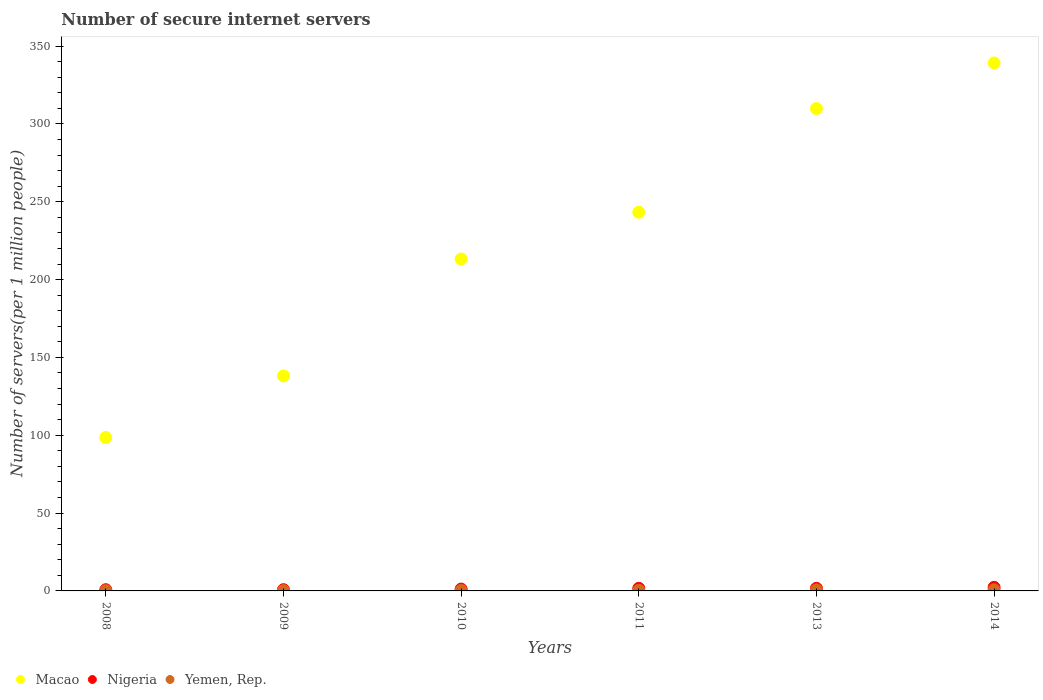What is the number of secure internet servers in Nigeria in 2008?
Offer a terse response. 0.79. Across all years, what is the maximum number of secure internet servers in Yemen, Rep.?
Give a very brief answer. 0.73. Across all years, what is the minimum number of secure internet servers in Yemen, Rep.?
Your response must be concise. 0.18. In which year was the number of secure internet servers in Macao maximum?
Provide a short and direct response. 2014. In which year was the number of secure internet servers in Macao minimum?
Provide a succinct answer. 2008. What is the total number of secure internet servers in Yemen, Rep. in the graph?
Your response must be concise. 2.46. What is the difference between the number of secure internet servers in Macao in 2010 and that in 2011?
Your answer should be very brief. -30.05. What is the difference between the number of secure internet servers in Macao in 2009 and the number of secure internet servers in Nigeria in 2010?
Your answer should be very brief. 136.89. What is the average number of secure internet servers in Macao per year?
Provide a short and direct response. 223.69. In the year 2014, what is the difference between the number of secure internet servers in Yemen, Rep. and number of secure internet servers in Macao?
Offer a very short reply. -338.43. What is the ratio of the number of secure internet servers in Yemen, Rep. in 2008 to that in 2009?
Your response must be concise. 0.82. Is the number of secure internet servers in Nigeria in 2009 less than that in 2010?
Make the answer very short. Yes. What is the difference between the highest and the second highest number of secure internet servers in Yemen, Rep.?
Make the answer very short. 0.1. What is the difference between the highest and the lowest number of secure internet servers in Nigeria?
Your answer should be very brief. 1.53. Is the sum of the number of secure internet servers in Yemen, Rep. in 2008 and 2013 greater than the maximum number of secure internet servers in Macao across all years?
Your answer should be compact. No. Is it the case that in every year, the sum of the number of secure internet servers in Macao and number of secure internet servers in Yemen, Rep.  is greater than the number of secure internet servers in Nigeria?
Ensure brevity in your answer.  Yes. Does the number of secure internet servers in Macao monotonically increase over the years?
Make the answer very short. Yes. Is the number of secure internet servers in Nigeria strictly less than the number of secure internet servers in Macao over the years?
Keep it short and to the point. Yes. How many years are there in the graph?
Provide a succinct answer. 6. Does the graph contain any zero values?
Your response must be concise. No. Does the graph contain grids?
Your response must be concise. No. How many legend labels are there?
Make the answer very short. 3. What is the title of the graph?
Provide a short and direct response. Number of secure internet servers. Does "Morocco" appear as one of the legend labels in the graph?
Ensure brevity in your answer.  No. What is the label or title of the Y-axis?
Keep it short and to the point. Number of servers(per 1 million people). What is the Number of servers(per 1 million people) in Macao in 2008?
Provide a succinct answer. 98.57. What is the Number of servers(per 1 million people) of Nigeria in 2008?
Offer a very short reply. 0.79. What is the Number of servers(per 1 million people) of Yemen, Rep. in 2008?
Keep it short and to the point. 0.18. What is the Number of servers(per 1 million people) of Macao in 2009?
Provide a short and direct response. 138.09. What is the Number of servers(per 1 million people) of Nigeria in 2009?
Give a very brief answer. 0.81. What is the Number of servers(per 1 million people) in Yemen, Rep. in 2009?
Make the answer very short. 0.22. What is the Number of servers(per 1 million people) in Macao in 2010?
Offer a very short reply. 213.23. What is the Number of servers(per 1 million people) of Nigeria in 2010?
Make the answer very short. 1.2. What is the Number of servers(per 1 million people) in Yemen, Rep. in 2010?
Give a very brief answer. 0.3. What is the Number of servers(per 1 million people) in Macao in 2011?
Your answer should be compact. 243.29. What is the Number of servers(per 1 million people) in Nigeria in 2011?
Your response must be concise. 1.68. What is the Number of servers(per 1 million people) of Yemen, Rep. in 2011?
Offer a very short reply. 0.41. What is the Number of servers(per 1 million people) in Macao in 2013?
Offer a terse response. 309.83. What is the Number of servers(per 1 million people) of Nigeria in 2013?
Provide a succinct answer. 1.68. What is the Number of servers(per 1 million people) of Yemen, Rep. in 2013?
Ensure brevity in your answer.  0.63. What is the Number of servers(per 1 million people) in Macao in 2014?
Your answer should be compact. 339.15. What is the Number of servers(per 1 million people) of Nigeria in 2014?
Your response must be concise. 2.32. What is the Number of servers(per 1 million people) of Yemen, Rep. in 2014?
Give a very brief answer. 0.73. Across all years, what is the maximum Number of servers(per 1 million people) of Macao?
Your answer should be very brief. 339.15. Across all years, what is the maximum Number of servers(per 1 million people) of Nigeria?
Your response must be concise. 2.32. Across all years, what is the maximum Number of servers(per 1 million people) of Yemen, Rep.?
Keep it short and to the point. 0.73. Across all years, what is the minimum Number of servers(per 1 million people) in Macao?
Give a very brief answer. 98.57. Across all years, what is the minimum Number of servers(per 1 million people) in Nigeria?
Make the answer very short. 0.79. Across all years, what is the minimum Number of servers(per 1 million people) of Yemen, Rep.?
Make the answer very short. 0.18. What is the total Number of servers(per 1 million people) in Macao in the graph?
Provide a succinct answer. 1342.15. What is the total Number of servers(per 1 million people) in Nigeria in the graph?
Your answer should be very brief. 8.48. What is the total Number of servers(per 1 million people) of Yemen, Rep. in the graph?
Your answer should be very brief. 2.46. What is the difference between the Number of servers(per 1 million people) in Macao in 2008 and that in 2009?
Your answer should be very brief. -39.52. What is the difference between the Number of servers(per 1 million people) in Nigeria in 2008 and that in 2009?
Provide a short and direct response. -0.01. What is the difference between the Number of servers(per 1 million people) of Yemen, Rep. in 2008 and that in 2009?
Ensure brevity in your answer.  -0.04. What is the difference between the Number of servers(per 1 million people) of Macao in 2008 and that in 2010?
Keep it short and to the point. -114.67. What is the difference between the Number of servers(per 1 million people) in Nigeria in 2008 and that in 2010?
Offer a terse response. -0.4. What is the difference between the Number of servers(per 1 million people) of Yemen, Rep. in 2008 and that in 2010?
Offer a very short reply. -0.12. What is the difference between the Number of servers(per 1 million people) of Macao in 2008 and that in 2011?
Offer a terse response. -144.72. What is the difference between the Number of servers(per 1 million people) of Nigeria in 2008 and that in 2011?
Give a very brief answer. -0.89. What is the difference between the Number of servers(per 1 million people) of Yemen, Rep. in 2008 and that in 2011?
Your answer should be very brief. -0.23. What is the difference between the Number of servers(per 1 million people) of Macao in 2008 and that in 2013?
Provide a succinct answer. -211.26. What is the difference between the Number of servers(per 1 million people) in Nigeria in 2008 and that in 2013?
Your answer should be very brief. -0.89. What is the difference between the Number of servers(per 1 million people) of Yemen, Rep. in 2008 and that in 2013?
Offer a terse response. -0.45. What is the difference between the Number of servers(per 1 million people) in Macao in 2008 and that in 2014?
Ensure brevity in your answer.  -240.58. What is the difference between the Number of servers(per 1 million people) of Nigeria in 2008 and that in 2014?
Provide a short and direct response. -1.53. What is the difference between the Number of servers(per 1 million people) in Yemen, Rep. in 2008 and that in 2014?
Give a very brief answer. -0.55. What is the difference between the Number of servers(per 1 million people) in Macao in 2009 and that in 2010?
Your answer should be compact. -75.14. What is the difference between the Number of servers(per 1 million people) in Nigeria in 2009 and that in 2010?
Offer a terse response. -0.39. What is the difference between the Number of servers(per 1 million people) of Yemen, Rep. in 2009 and that in 2010?
Your answer should be very brief. -0.08. What is the difference between the Number of servers(per 1 million people) of Macao in 2009 and that in 2011?
Offer a terse response. -105.2. What is the difference between the Number of servers(per 1 million people) in Nigeria in 2009 and that in 2011?
Give a very brief answer. -0.87. What is the difference between the Number of servers(per 1 million people) in Yemen, Rep. in 2009 and that in 2011?
Your response must be concise. -0.19. What is the difference between the Number of servers(per 1 million people) of Macao in 2009 and that in 2013?
Your answer should be very brief. -171.74. What is the difference between the Number of servers(per 1 million people) in Nigeria in 2009 and that in 2013?
Provide a short and direct response. -0.88. What is the difference between the Number of servers(per 1 million people) in Yemen, Rep. in 2009 and that in 2013?
Offer a very short reply. -0.41. What is the difference between the Number of servers(per 1 million people) in Macao in 2009 and that in 2014?
Provide a succinct answer. -201.06. What is the difference between the Number of servers(per 1 million people) in Nigeria in 2009 and that in 2014?
Your answer should be compact. -1.52. What is the difference between the Number of servers(per 1 million people) of Yemen, Rep. in 2009 and that in 2014?
Provide a short and direct response. -0.51. What is the difference between the Number of servers(per 1 million people) of Macao in 2010 and that in 2011?
Your answer should be very brief. -30.05. What is the difference between the Number of servers(per 1 million people) of Nigeria in 2010 and that in 2011?
Your answer should be compact. -0.48. What is the difference between the Number of servers(per 1 million people) in Yemen, Rep. in 2010 and that in 2011?
Your answer should be compact. -0.12. What is the difference between the Number of servers(per 1 million people) of Macao in 2010 and that in 2013?
Your response must be concise. -96.6. What is the difference between the Number of servers(per 1 million people) in Nigeria in 2010 and that in 2013?
Your answer should be very brief. -0.49. What is the difference between the Number of servers(per 1 million people) of Yemen, Rep. in 2010 and that in 2013?
Your answer should be very brief. -0.33. What is the difference between the Number of servers(per 1 million people) in Macao in 2010 and that in 2014?
Make the answer very short. -125.92. What is the difference between the Number of servers(per 1 million people) in Nigeria in 2010 and that in 2014?
Your answer should be compact. -1.12. What is the difference between the Number of servers(per 1 million people) in Yemen, Rep. in 2010 and that in 2014?
Your answer should be very brief. -0.43. What is the difference between the Number of servers(per 1 million people) of Macao in 2011 and that in 2013?
Make the answer very short. -66.54. What is the difference between the Number of servers(per 1 million people) of Nigeria in 2011 and that in 2013?
Offer a terse response. -0. What is the difference between the Number of servers(per 1 million people) in Yemen, Rep. in 2011 and that in 2013?
Make the answer very short. -0.21. What is the difference between the Number of servers(per 1 million people) of Macao in 2011 and that in 2014?
Your response must be concise. -95.86. What is the difference between the Number of servers(per 1 million people) in Nigeria in 2011 and that in 2014?
Your answer should be compact. -0.64. What is the difference between the Number of servers(per 1 million people) of Yemen, Rep. in 2011 and that in 2014?
Your response must be concise. -0.31. What is the difference between the Number of servers(per 1 million people) in Macao in 2013 and that in 2014?
Your response must be concise. -29.32. What is the difference between the Number of servers(per 1 million people) in Nigeria in 2013 and that in 2014?
Your answer should be compact. -0.64. What is the difference between the Number of servers(per 1 million people) in Yemen, Rep. in 2013 and that in 2014?
Keep it short and to the point. -0.1. What is the difference between the Number of servers(per 1 million people) of Macao in 2008 and the Number of servers(per 1 million people) of Nigeria in 2009?
Give a very brief answer. 97.76. What is the difference between the Number of servers(per 1 million people) in Macao in 2008 and the Number of servers(per 1 million people) in Yemen, Rep. in 2009?
Your answer should be very brief. 98.35. What is the difference between the Number of servers(per 1 million people) of Nigeria in 2008 and the Number of servers(per 1 million people) of Yemen, Rep. in 2009?
Provide a short and direct response. 0.58. What is the difference between the Number of servers(per 1 million people) of Macao in 2008 and the Number of servers(per 1 million people) of Nigeria in 2010?
Offer a very short reply. 97.37. What is the difference between the Number of servers(per 1 million people) in Macao in 2008 and the Number of servers(per 1 million people) in Yemen, Rep. in 2010?
Provide a succinct answer. 98.27. What is the difference between the Number of servers(per 1 million people) in Nigeria in 2008 and the Number of servers(per 1 million people) in Yemen, Rep. in 2010?
Make the answer very short. 0.5. What is the difference between the Number of servers(per 1 million people) of Macao in 2008 and the Number of servers(per 1 million people) of Nigeria in 2011?
Offer a very short reply. 96.89. What is the difference between the Number of servers(per 1 million people) in Macao in 2008 and the Number of servers(per 1 million people) in Yemen, Rep. in 2011?
Give a very brief answer. 98.15. What is the difference between the Number of servers(per 1 million people) in Nigeria in 2008 and the Number of servers(per 1 million people) in Yemen, Rep. in 2011?
Provide a short and direct response. 0.38. What is the difference between the Number of servers(per 1 million people) of Macao in 2008 and the Number of servers(per 1 million people) of Nigeria in 2013?
Your answer should be compact. 96.88. What is the difference between the Number of servers(per 1 million people) of Macao in 2008 and the Number of servers(per 1 million people) of Yemen, Rep. in 2013?
Provide a short and direct response. 97.94. What is the difference between the Number of servers(per 1 million people) of Nigeria in 2008 and the Number of servers(per 1 million people) of Yemen, Rep. in 2013?
Ensure brevity in your answer.  0.17. What is the difference between the Number of servers(per 1 million people) in Macao in 2008 and the Number of servers(per 1 million people) in Nigeria in 2014?
Provide a succinct answer. 96.24. What is the difference between the Number of servers(per 1 million people) in Macao in 2008 and the Number of servers(per 1 million people) in Yemen, Rep. in 2014?
Your answer should be compact. 97.84. What is the difference between the Number of servers(per 1 million people) in Nigeria in 2008 and the Number of servers(per 1 million people) in Yemen, Rep. in 2014?
Provide a short and direct response. 0.07. What is the difference between the Number of servers(per 1 million people) of Macao in 2009 and the Number of servers(per 1 million people) of Nigeria in 2010?
Keep it short and to the point. 136.89. What is the difference between the Number of servers(per 1 million people) in Macao in 2009 and the Number of servers(per 1 million people) in Yemen, Rep. in 2010?
Make the answer very short. 137.79. What is the difference between the Number of servers(per 1 million people) of Nigeria in 2009 and the Number of servers(per 1 million people) of Yemen, Rep. in 2010?
Make the answer very short. 0.51. What is the difference between the Number of servers(per 1 million people) in Macao in 2009 and the Number of servers(per 1 million people) in Nigeria in 2011?
Provide a succinct answer. 136.41. What is the difference between the Number of servers(per 1 million people) in Macao in 2009 and the Number of servers(per 1 million people) in Yemen, Rep. in 2011?
Your answer should be very brief. 137.68. What is the difference between the Number of servers(per 1 million people) of Nigeria in 2009 and the Number of servers(per 1 million people) of Yemen, Rep. in 2011?
Keep it short and to the point. 0.39. What is the difference between the Number of servers(per 1 million people) in Macao in 2009 and the Number of servers(per 1 million people) in Nigeria in 2013?
Provide a short and direct response. 136.4. What is the difference between the Number of servers(per 1 million people) in Macao in 2009 and the Number of servers(per 1 million people) in Yemen, Rep. in 2013?
Your response must be concise. 137.46. What is the difference between the Number of servers(per 1 million people) of Nigeria in 2009 and the Number of servers(per 1 million people) of Yemen, Rep. in 2013?
Offer a terse response. 0.18. What is the difference between the Number of servers(per 1 million people) of Macao in 2009 and the Number of servers(per 1 million people) of Nigeria in 2014?
Provide a short and direct response. 135.77. What is the difference between the Number of servers(per 1 million people) in Macao in 2009 and the Number of servers(per 1 million people) in Yemen, Rep. in 2014?
Offer a terse response. 137.36. What is the difference between the Number of servers(per 1 million people) in Nigeria in 2009 and the Number of servers(per 1 million people) in Yemen, Rep. in 2014?
Your answer should be compact. 0.08. What is the difference between the Number of servers(per 1 million people) in Macao in 2010 and the Number of servers(per 1 million people) in Nigeria in 2011?
Make the answer very short. 211.55. What is the difference between the Number of servers(per 1 million people) of Macao in 2010 and the Number of servers(per 1 million people) of Yemen, Rep. in 2011?
Offer a terse response. 212.82. What is the difference between the Number of servers(per 1 million people) of Nigeria in 2010 and the Number of servers(per 1 million people) of Yemen, Rep. in 2011?
Give a very brief answer. 0.79. What is the difference between the Number of servers(per 1 million people) in Macao in 2010 and the Number of servers(per 1 million people) in Nigeria in 2013?
Ensure brevity in your answer.  211.55. What is the difference between the Number of servers(per 1 million people) of Macao in 2010 and the Number of servers(per 1 million people) of Yemen, Rep. in 2013?
Provide a succinct answer. 212.61. What is the difference between the Number of servers(per 1 million people) in Nigeria in 2010 and the Number of servers(per 1 million people) in Yemen, Rep. in 2013?
Make the answer very short. 0.57. What is the difference between the Number of servers(per 1 million people) of Macao in 2010 and the Number of servers(per 1 million people) of Nigeria in 2014?
Give a very brief answer. 210.91. What is the difference between the Number of servers(per 1 million people) in Macao in 2010 and the Number of servers(per 1 million people) in Yemen, Rep. in 2014?
Make the answer very short. 212.51. What is the difference between the Number of servers(per 1 million people) in Nigeria in 2010 and the Number of servers(per 1 million people) in Yemen, Rep. in 2014?
Offer a terse response. 0.47. What is the difference between the Number of servers(per 1 million people) of Macao in 2011 and the Number of servers(per 1 million people) of Nigeria in 2013?
Keep it short and to the point. 241.6. What is the difference between the Number of servers(per 1 million people) in Macao in 2011 and the Number of servers(per 1 million people) in Yemen, Rep. in 2013?
Provide a short and direct response. 242.66. What is the difference between the Number of servers(per 1 million people) of Nigeria in 2011 and the Number of servers(per 1 million people) of Yemen, Rep. in 2013?
Provide a succinct answer. 1.05. What is the difference between the Number of servers(per 1 million people) of Macao in 2011 and the Number of servers(per 1 million people) of Nigeria in 2014?
Provide a short and direct response. 240.96. What is the difference between the Number of servers(per 1 million people) in Macao in 2011 and the Number of servers(per 1 million people) in Yemen, Rep. in 2014?
Give a very brief answer. 242.56. What is the difference between the Number of servers(per 1 million people) in Nigeria in 2011 and the Number of servers(per 1 million people) in Yemen, Rep. in 2014?
Your answer should be compact. 0.95. What is the difference between the Number of servers(per 1 million people) in Macao in 2013 and the Number of servers(per 1 million people) in Nigeria in 2014?
Your answer should be very brief. 307.51. What is the difference between the Number of servers(per 1 million people) in Macao in 2013 and the Number of servers(per 1 million people) in Yemen, Rep. in 2014?
Your answer should be very brief. 309.1. What is the difference between the Number of servers(per 1 million people) in Nigeria in 2013 and the Number of servers(per 1 million people) in Yemen, Rep. in 2014?
Provide a succinct answer. 0.96. What is the average Number of servers(per 1 million people) in Macao per year?
Your answer should be very brief. 223.69. What is the average Number of servers(per 1 million people) of Nigeria per year?
Make the answer very short. 1.41. What is the average Number of servers(per 1 million people) in Yemen, Rep. per year?
Make the answer very short. 0.41. In the year 2008, what is the difference between the Number of servers(per 1 million people) in Macao and Number of servers(per 1 million people) in Nigeria?
Offer a very short reply. 97.77. In the year 2008, what is the difference between the Number of servers(per 1 million people) in Macao and Number of servers(per 1 million people) in Yemen, Rep.?
Make the answer very short. 98.39. In the year 2008, what is the difference between the Number of servers(per 1 million people) in Nigeria and Number of servers(per 1 million people) in Yemen, Rep.?
Your answer should be compact. 0.61. In the year 2009, what is the difference between the Number of servers(per 1 million people) in Macao and Number of servers(per 1 million people) in Nigeria?
Keep it short and to the point. 137.28. In the year 2009, what is the difference between the Number of servers(per 1 million people) of Macao and Number of servers(per 1 million people) of Yemen, Rep.?
Keep it short and to the point. 137.87. In the year 2009, what is the difference between the Number of servers(per 1 million people) of Nigeria and Number of servers(per 1 million people) of Yemen, Rep.?
Provide a succinct answer. 0.59. In the year 2010, what is the difference between the Number of servers(per 1 million people) in Macao and Number of servers(per 1 million people) in Nigeria?
Provide a succinct answer. 212.04. In the year 2010, what is the difference between the Number of servers(per 1 million people) of Macao and Number of servers(per 1 million people) of Yemen, Rep.?
Your answer should be compact. 212.94. In the year 2010, what is the difference between the Number of servers(per 1 million people) in Nigeria and Number of servers(per 1 million people) in Yemen, Rep.?
Offer a terse response. 0.9. In the year 2011, what is the difference between the Number of servers(per 1 million people) in Macao and Number of servers(per 1 million people) in Nigeria?
Provide a succinct answer. 241.61. In the year 2011, what is the difference between the Number of servers(per 1 million people) in Macao and Number of servers(per 1 million people) in Yemen, Rep.?
Your response must be concise. 242.87. In the year 2011, what is the difference between the Number of servers(per 1 million people) of Nigeria and Number of servers(per 1 million people) of Yemen, Rep.?
Offer a terse response. 1.27. In the year 2013, what is the difference between the Number of servers(per 1 million people) of Macao and Number of servers(per 1 million people) of Nigeria?
Offer a terse response. 308.14. In the year 2013, what is the difference between the Number of servers(per 1 million people) of Macao and Number of servers(per 1 million people) of Yemen, Rep.?
Provide a short and direct response. 309.2. In the year 2013, what is the difference between the Number of servers(per 1 million people) in Nigeria and Number of servers(per 1 million people) in Yemen, Rep.?
Give a very brief answer. 1.06. In the year 2014, what is the difference between the Number of servers(per 1 million people) of Macao and Number of servers(per 1 million people) of Nigeria?
Keep it short and to the point. 336.83. In the year 2014, what is the difference between the Number of servers(per 1 million people) of Macao and Number of servers(per 1 million people) of Yemen, Rep.?
Your answer should be very brief. 338.43. In the year 2014, what is the difference between the Number of servers(per 1 million people) of Nigeria and Number of servers(per 1 million people) of Yemen, Rep.?
Offer a terse response. 1.6. What is the ratio of the Number of servers(per 1 million people) in Macao in 2008 to that in 2009?
Offer a very short reply. 0.71. What is the ratio of the Number of servers(per 1 million people) of Nigeria in 2008 to that in 2009?
Offer a terse response. 0.99. What is the ratio of the Number of servers(per 1 million people) in Yemen, Rep. in 2008 to that in 2009?
Make the answer very short. 0.82. What is the ratio of the Number of servers(per 1 million people) of Macao in 2008 to that in 2010?
Give a very brief answer. 0.46. What is the ratio of the Number of servers(per 1 million people) in Nigeria in 2008 to that in 2010?
Ensure brevity in your answer.  0.66. What is the ratio of the Number of servers(per 1 million people) of Yemen, Rep. in 2008 to that in 2010?
Offer a very short reply. 0.6. What is the ratio of the Number of servers(per 1 million people) in Macao in 2008 to that in 2011?
Your response must be concise. 0.41. What is the ratio of the Number of servers(per 1 million people) in Nigeria in 2008 to that in 2011?
Make the answer very short. 0.47. What is the ratio of the Number of servers(per 1 million people) of Yemen, Rep. in 2008 to that in 2011?
Keep it short and to the point. 0.43. What is the ratio of the Number of servers(per 1 million people) of Macao in 2008 to that in 2013?
Provide a succinct answer. 0.32. What is the ratio of the Number of servers(per 1 million people) in Nigeria in 2008 to that in 2013?
Keep it short and to the point. 0.47. What is the ratio of the Number of servers(per 1 million people) in Yemen, Rep. in 2008 to that in 2013?
Ensure brevity in your answer.  0.29. What is the ratio of the Number of servers(per 1 million people) of Macao in 2008 to that in 2014?
Your response must be concise. 0.29. What is the ratio of the Number of servers(per 1 million people) of Nigeria in 2008 to that in 2014?
Your answer should be very brief. 0.34. What is the ratio of the Number of servers(per 1 million people) in Yemen, Rep. in 2008 to that in 2014?
Offer a terse response. 0.25. What is the ratio of the Number of servers(per 1 million people) of Macao in 2009 to that in 2010?
Your answer should be compact. 0.65. What is the ratio of the Number of servers(per 1 million people) in Nigeria in 2009 to that in 2010?
Make the answer very short. 0.67. What is the ratio of the Number of servers(per 1 million people) of Yemen, Rep. in 2009 to that in 2010?
Your answer should be very brief. 0.73. What is the ratio of the Number of servers(per 1 million people) of Macao in 2009 to that in 2011?
Provide a short and direct response. 0.57. What is the ratio of the Number of servers(per 1 million people) of Nigeria in 2009 to that in 2011?
Offer a very short reply. 0.48. What is the ratio of the Number of servers(per 1 million people) of Yemen, Rep. in 2009 to that in 2011?
Make the answer very short. 0.53. What is the ratio of the Number of servers(per 1 million people) in Macao in 2009 to that in 2013?
Make the answer very short. 0.45. What is the ratio of the Number of servers(per 1 million people) of Nigeria in 2009 to that in 2013?
Offer a very short reply. 0.48. What is the ratio of the Number of servers(per 1 million people) of Yemen, Rep. in 2009 to that in 2013?
Give a very brief answer. 0.35. What is the ratio of the Number of servers(per 1 million people) in Macao in 2009 to that in 2014?
Your answer should be very brief. 0.41. What is the ratio of the Number of servers(per 1 million people) of Nigeria in 2009 to that in 2014?
Offer a terse response. 0.35. What is the ratio of the Number of servers(per 1 million people) in Yemen, Rep. in 2009 to that in 2014?
Your response must be concise. 0.3. What is the ratio of the Number of servers(per 1 million people) in Macao in 2010 to that in 2011?
Give a very brief answer. 0.88. What is the ratio of the Number of servers(per 1 million people) in Nigeria in 2010 to that in 2011?
Your response must be concise. 0.71. What is the ratio of the Number of servers(per 1 million people) in Yemen, Rep. in 2010 to that in 2011?
Provide a succinct answer. 0.72. What is the ratio of the Number of servers(per 1 million people) of Macao in 2010 to that in 2013?
Your answer should be compact. 0.69. What is the ratio of the Number of servers(per 1 million people) of Nigeria in 2010 to that in 2013?
Your response must be concise. 0.71. What is the ratio of the Number of servers(per 1 million people) in Yemen, Rep. in 2010 to that in 2013?
Provide a succinct answer. 0.47. What is the ratio of the Number of servers(per 1 million people) of Macao in 2010 to that in 2014?
Give a very brief answer. 0.63. What is the ratio of the Number of servers(per 1 million people) in Nigeria in 2010 to that in 2014?
Give a very brief answer. 0.52. What is the ratio of the Number of servers(per 1 million people) of Yemen, Rep. in 2010 to that in 2014?
Provide a succinct answer. 0.41. What is the ratio of the Number of servers(per 1 million people) in Macao in 2011 to that in 2013?
Ensure brevity in your answer.  0.79. What is the ratio of the Number of servers(per 1 million people) of Nigeria in 2011 to that in 2013?
Ensure brevity in your answer.  1. What is the ratio of the Number of servers(per 1 million people) in Yemen, Rep. in 2011 to that in 2013?
Keep it short and to the point. 0.66. What is the ratio of the Number of servers(per 1 million people) in Macao in 2011 to that in 2014?
Offer a very short reply. 0.72. What is the ratio of the Number of servers(per 1 million people) in Nigeria in 2011 to that in 2014?
Offer a very short reply. 0.72. What is the ratio of the Number of servers(per 1 million people) in Yemen, Rep. in 2011 to that in 2014?
Your answer should be very brief. 0.57. What is the ratio of the Number of servers(per 1 million people) in Macao in 2013 to that in 2014?
Provide a short and direct response. 0.91. What is the ratio of the Number of servers(per 1 million people) in Nigeria in 2013 to that in 2014?
Provide a succinct answer. 0.73. What is the ratio of the Number of servers(per 1 million people) in Yemen, Rep. in 2013 to that in 2014?
Give a very brief answer. 0.86. What is the difference between the highest and the second highest Number of servers(per 1 million people) in Macao?
Provide a short and direct response. 29.32. What is the difference between the highest and the second highest Number of servers(per 1 million people) in Nigeria?
Your answer should be compact. 0.64. What is the difference between the highest and the second highest Number of servers(per 1 million people) of Yemen, Rep.?
Your response must be concise. 0.1. What is the difference between the highest and the lowest Number of servers(per 1 million people) in Macao?
Your response must be concise. 240.58. What is the difference between the highest and the lowest Number of servers(per 1 million people) of Nigeria?
Provide a short and direct response. 1.53. What is the difference between the highest and the lowest Number of servers(per 1 million people) of Yemen, Rep.?
Provide a short and direct response. 0.55. 